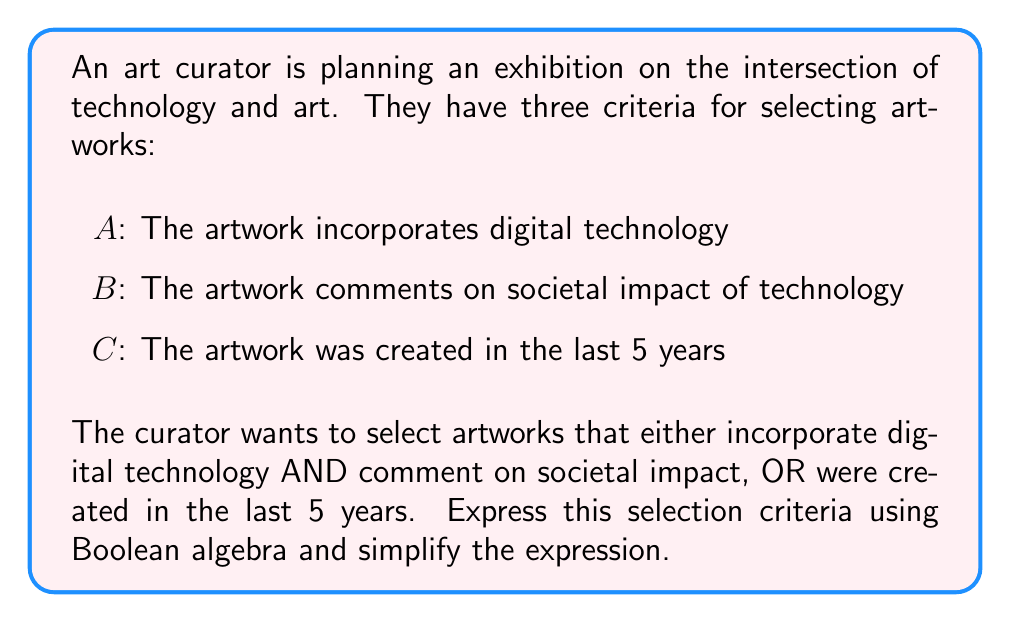Provide a solution to this math problem. Let's approach this step-by-step:

1) First, we need to translate the curator's criteria into a Boolean expression:

   $(A \land B) \lor C$

   Where $\land$ represents AND, and $\lor$ represents OR.

2) This expression is already in its simplest form, known as disjunctive normal form (DNF). However, we can explore it further to understand its implications:

3) We can use the distributive law to expand this expression:

   $(A \land B) \lor C = (A \lor C) \land (B \lor C)$

4) This expanded form shows that for an artwork to be selected, it must satisfy either of these conditions:
   - It incorporates digital technology (A) OR was created in the last 5 years (C)
   AND
   - It comments on societal impact (B) OR was created in the last 5 years (C)

5) From an art history perspective, this Boolean model reveals that the curator's criteria place a strong emphasis on recent works (C), as they can bypass both the digital technology and societal impact requirements.

6) The model also shows that for older works (not C), they must satisfy both the digital technology (A) and societal impact (B) criteria to be included.

This Boolean model provides a clear, logical framework for the curator's decision-making process, allowing for a systematic approach to artwork selection while balancing technological, societal, and contemporary aspects of the exhibition.
Answer: $(A \land B) \lor C$ 